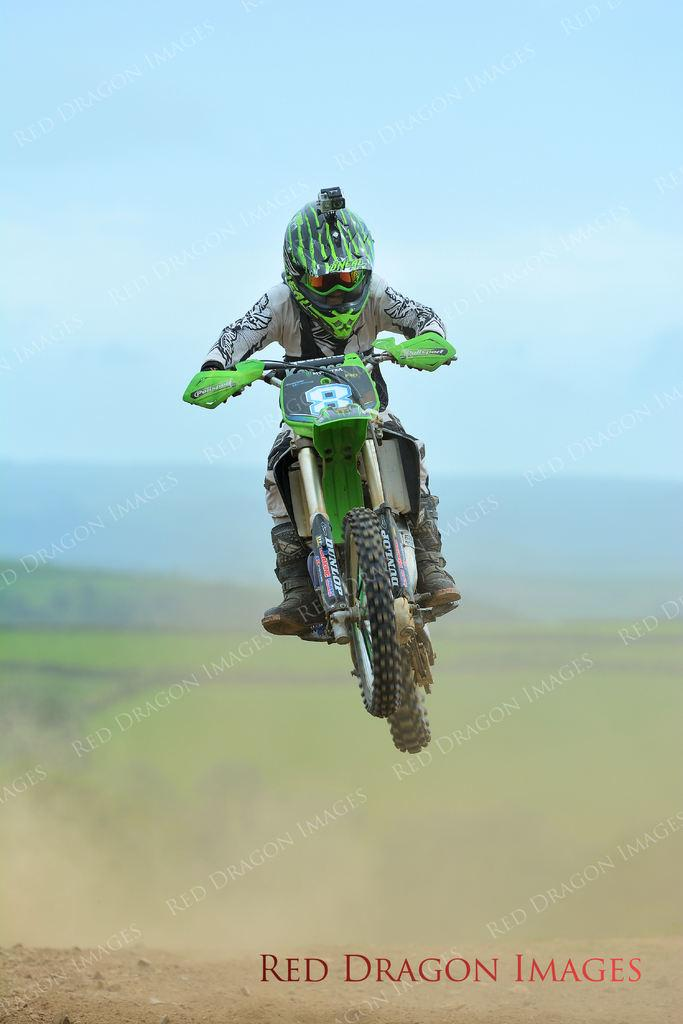What is the main subject of the image? There is a person in the image. What is the person doing in the image? The person is riding a bike. Can you describe the person's position in the image? The person is in the air. How does the background appear in the image? The background is blurred in the image. What can be seen in the sky in the image? The sky is visible in the image. What type of sound can be heard coming from the eggnog in the image? There is no eggnog present in the image, so it's not possible to determine what, if any, sound might be heard. 